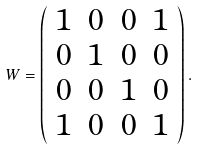Convert formula to latex. <formula><loc_0><loc_0><loc_500><loc_500>W = \left ( \begin{array} { c c c c } 1 & 0 & 0 & 1 \\ 0 & 1 & 0 & 0 \\ 0 & 0 & 1 & 0 \\ 1 & 0 & 0 & 1 \end{array} \right ) .</formula> 